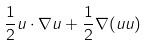Convert formula to latex. <formula><loc_0><loc_0><loc_500><loc_500>\frac { 1 } { 2 } u \cdot \nabla u + \frac { 1 } { 2 } \nabla ( u u )</formula> 